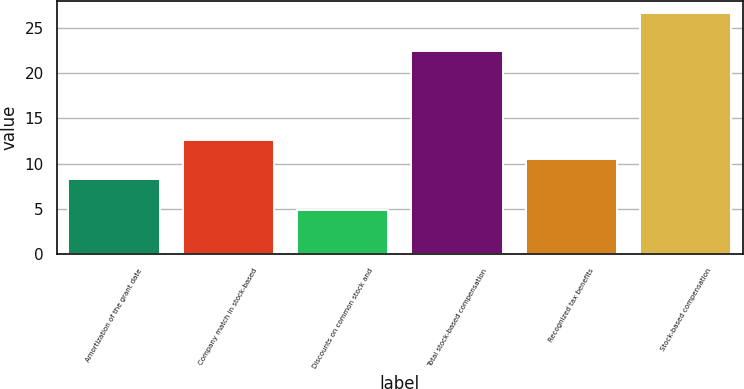<chart> <loc_0><loc_0><loc_500><loc_500><bar_chart><fcel>Amortization of the grant date<fcel>Company match in stock-based<fcel>Discounts on common stock and<fcel>Total stock-based compensation<fcel>Recognized tax benefits<fcel>Stock-based compensation<nl><fcel>8.3<fcel>12.64<fcel>4.9<fcel>22.4<fcel>10.47<fcel>26.6<nl></chart> 